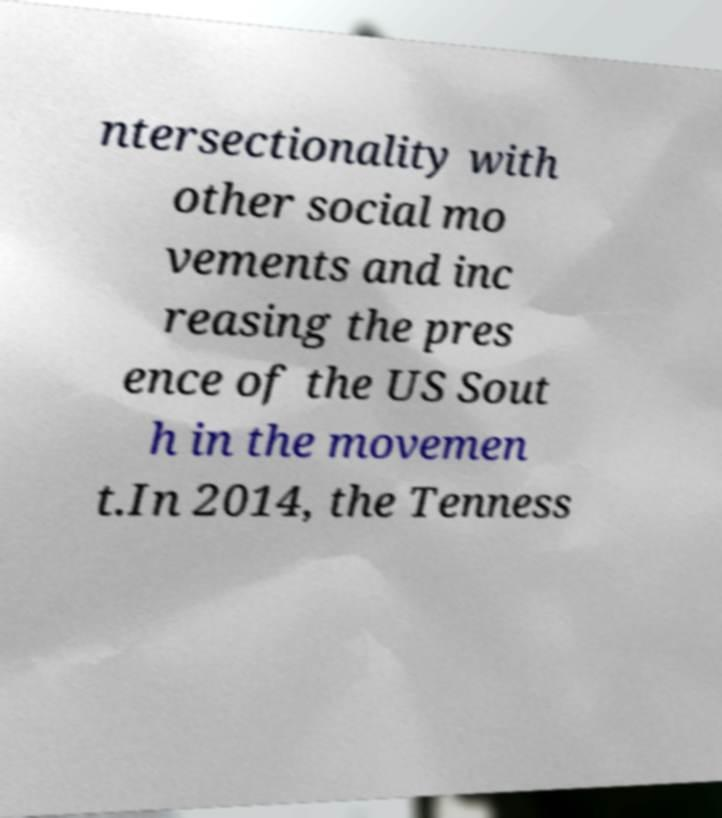Can you accurately transcribe the text from the provided image for me? ntersectionality with other social mo vements and inc reasing the pres ence of the US Sout h in the movemen t.In 2014, the Tenness 